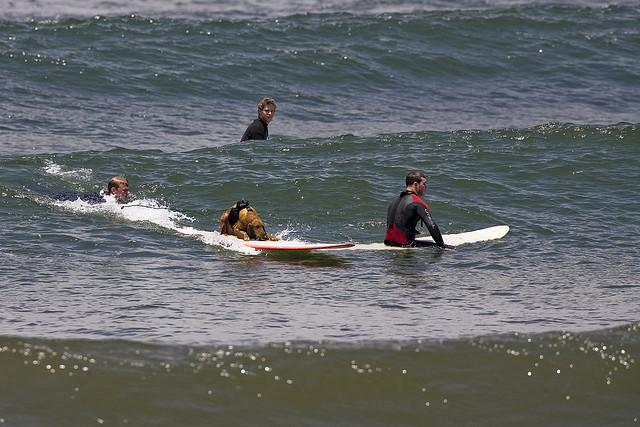What is the dog doing?

Choices:
A) biting
B) swimming
C) surfing
D) dog paddling surfing 